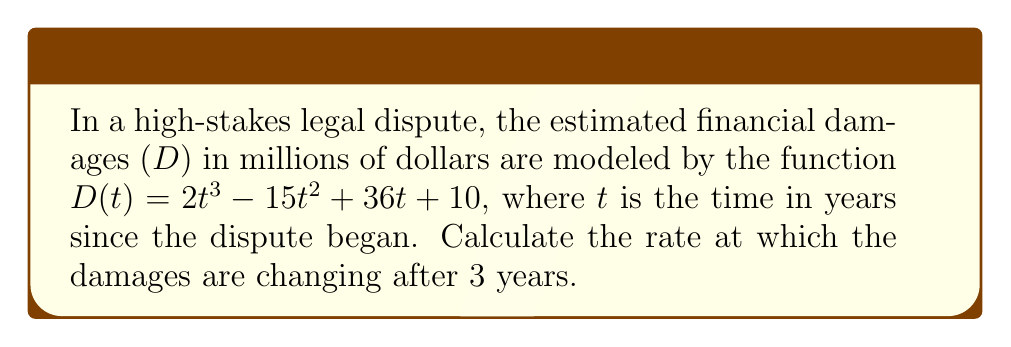What is the answer to this math problem? To solve this problem, we need to find the derivative of the damages function and evaluate it at t = 3. This will give us the instantaneous rate of change of the damages after 3 years.

1. First, let's find the derivative of D(t):
   $$\frac{d}{dt}D(t) = \frac{d}{dt}(2t^3 - 15t^2 + 36t + 10)$$
   $$D'(t) = 6t^2 - 30t + 36$$

2. Now, we need to evaluate D'(t) at t = 3:
   $$D'(3) = 6(3)^2 - 30(3) + 36$$
   $$= 6(9) - 90 + 36$$
   $$= 54 - 90 + 36$$
   $$= 0$$

3. Interpret the result:
   The rate of change of damages at t = 3 is 0 million dollars per year. This means that after 3 years, the damages are momentarily neither increasing nor decreasing.
Answer: $0$ million dollars per year 